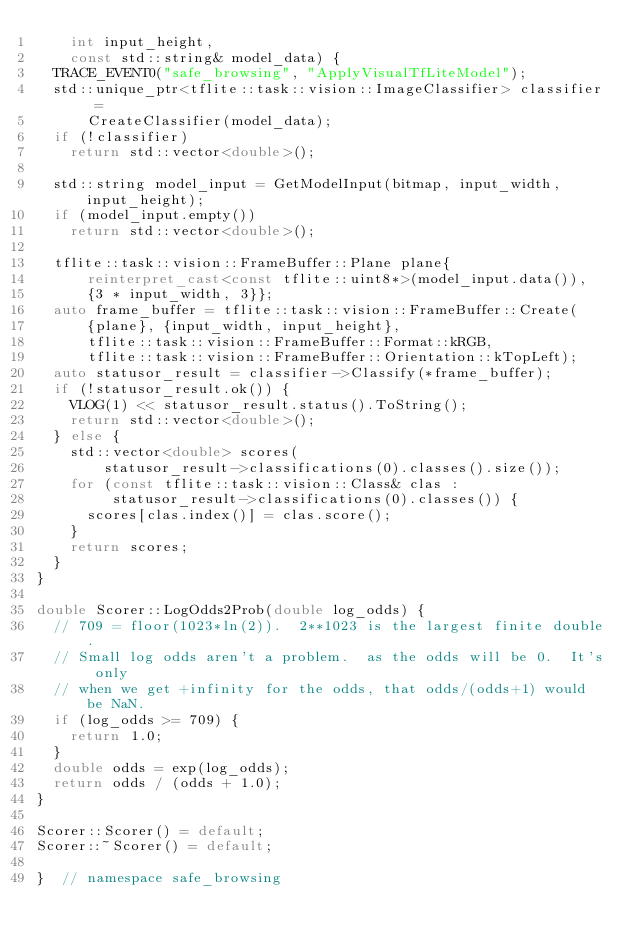Convert code to text. <code><loc_0><loc_0><loc_500><loc_500><_C++_>    int input_height,
    const std::string& model_data) {
  TRACE_EVENT0("safe_browsing", "ApplyVisualTfLiteModel");
  std::unique_ptr<tflite::task::vision::ImageClassifier> classifier =
      CreateClassifier(model_data);
  if (!classifier)
    return std::vector<double>();

  std::string model_input = GetModelInput(bitmap, input_width, input_height);
  if (model_input.empty())
    return std::vector<double>();

  tflite::task::vision::FrameBuffer::Plane plane{
      reinterpret_cast<const tflite::uint8*>(model_input.data()),
      {3 * input_width, 3}};
  auto frame_buffer = tflite::task::vision::FrameBuffer::Create(
      {plane}, {input_width, input_height},
      tflite::task::vision::FrameBuffer::Format::kRGB,
      tflite::task::vision::FrameBuffer::Orientation::kTopLeft);
  auto statusor_result = classifier->Classify(*frame_buffer);
  if (!statusor_result.ok()) {
    VLOG(1) << statusor_result.status().ToString();
    return std::vector<double>();
  } else {
    std::vector<double> scores(
        statusor_result->classifications(0).classes().size());
    for (const tflite::task::vision::Class& clas :
         statusor_result->classifications(0).classes()) {
      scores[clas.index()] = clas.score();
    }
    return scores;
  }
}

double Scorer::LogOdds2Prob(double log_odds) {
  // 709 = floor(1023*ln(2)).  2**1023 is the largest finite double.
  // Small log odds aren't a problem.  as the odds will be 0.  It's only
  // when we get +infinity for the odds, that odds/(odds+1) would be NaN.
  if (log_odds >= 709) {
    return 1.0;
  }
  double odds = exp(log_odds);
  return odds / (odds + 1.0);
}

Scorer::Scorer() = default;
Scorer::~Scorer() = default;

}  // namespace safe_browsing
</code> 